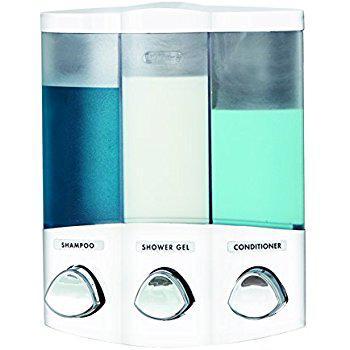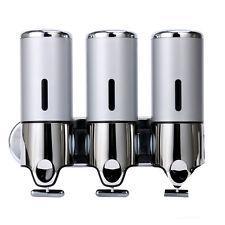The first image is the image on the left, the second image is the image on the right. For the images displayed, is the sentence "there is exactly one dispensing button in one of the images" factually correct? Answer yes or no. No. 